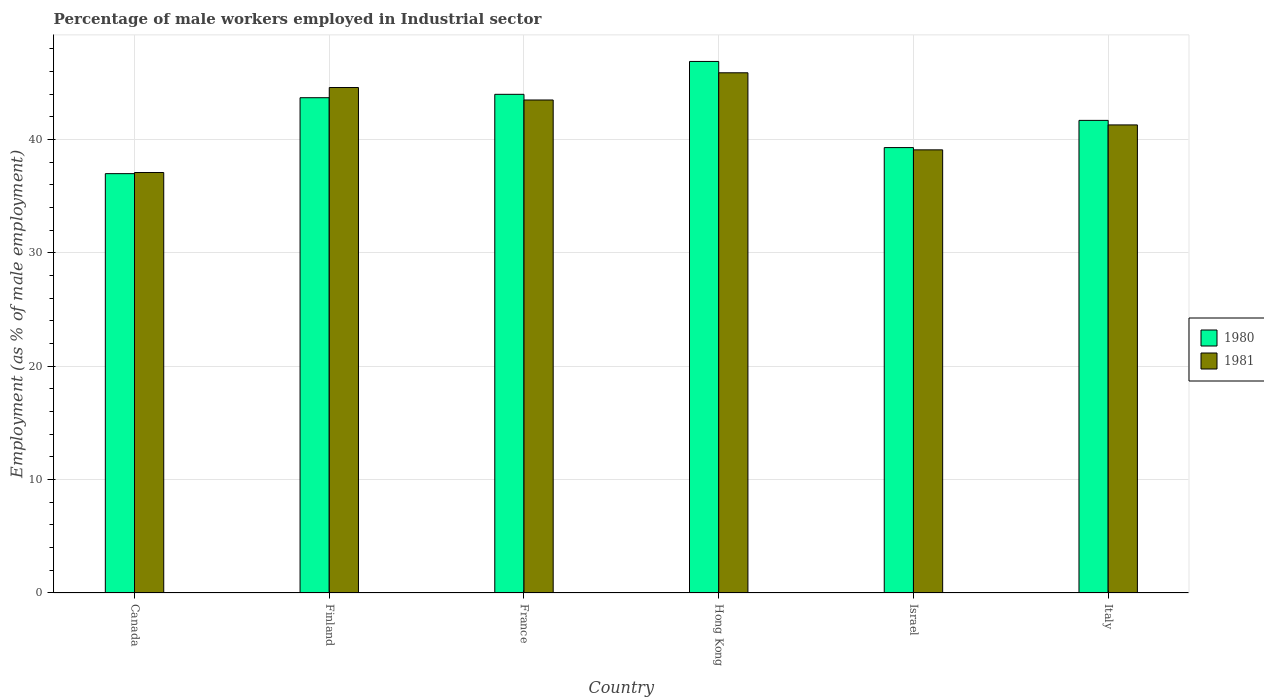How many different coloured bars are there?
Provide a succinct answer. 2. How many groups of bars are there?
Ensure brevity in your answer.  6. Are the number of bars on each tick of the X-axis equal?
Your answer should be very brief. Yes. In how many cases, is the number of bars for a given country not equal to the number of legend labels?
Your response must be concise. 0. What is the percentage of male workers employed in Industrial sector in 1980 in Italy?
Give a very brief answer. 41.7. Across all countries, what is the maximum percentage of male workers employed in Industrial sector in 1980?
Keep it short and to the point. 46.9. Across all countries, what is the minimum percentage of male workers employed in Industrial sector in 1981?
Make the answer very short. 37.1. In which country was the percentage of male workers employed in Industrial sector in 1980 maximum?
Offer a very short reply. Hong Kong. What is the total percentage of male workers employed in Industrial sector in 1980 in the graph?
Provide a short and direct response. 252.6. What is the difference between the percentage of male workers employed in Industrial sector in 1981 in Canada and that in Finland?
Give a very brief answer. -7.5. What is the difference between the percentage of male workers employed in Industrial sector in 1980 in Israel and the percentage of male workers employed in Industrial sector in 1981 in Canada?
Offer a terse response. 2.2. What is the average percentage of male workers employed in Industrial sector in 1980 per country?
Your answer should be very brief. 42.1. What is the difference between the percentage of male workers employed in Industrial sector of/in 1980 and percentage of male workers employed in Industrial sector of/in 1981 in Finland?
Ensure brevity in your answer.  -0.9. In how many countries, is the percentage of male workers employed in Industrial sector in 1980 greater than 30 %?
Ensure brevity in your answer.  6. What is the ratio of the percentage of male workers employed in Industrial sector in 1980 in Canada to that in Finland?
Your answer should be very brief. 0.85. Is the percentage of male workers employed in Industrial sector in 1980 in Canada less than that in Israel?
Provide a succinct answer. Yes. What is the difference between the highest and the second highest percentage of male workers employed in Industrial sector in 1980?
Your answer should be compact. -0.3. What is the difference between the highest and the lowest percentage of male workers employed in Industrial sector in 1980?
Make the answer very short. 9.9. What does the 1st bar from the left in Finland represents?
Offer a very short reply. 1980. How many countries are there in the graph?
Provide a succinct answer. 6. Does the graph contain grids?
Give a very brief answer. Yes. Where does the legend appear in the graph?
Keep it short and to the point. Center right. How many legend labels are there?
Provide a succinct answer. 2. What is the title of the graph?
Offer a terse response. Percentage of male workers employed in Industrial sector. Does "2002" appear as one of the legend labels in the graph?
Your response must be concise. No. What is the label or title of the Y-axis?
Offer a very short reply. Employment (as % of male employment). What is the Employment (as % of male employment) of 1980 in Canada?
Provide a succinct answer. 37. What is the Employment (as % of male employment) of 1981 in Canada?
Your answer should be compact. 37.1. What is the Employment (as % of male employment) of 1980 in Finland?
Offer a terse response. 43.7. What is the Employment (as % of male employment) in 1981 in Finland?
Your answer should be compact. 44.6. What is the Employment (as % of male employment) of 1980 in France?
Provide a succinct answer. 44. What is the Employment (as % of male employment) in 1981 in France?
Provide a succinct answer. 43.5. What is the Employment (as % of male employment) in 1980 in Hong Kong?
Your answer should be compact. 46.9. What is the Employment (as % of male employment) in 1981 in Hong Kong?
Provide a succinct answer. 45.9. What is the Employment (as % of male employment) of 1980 in Israel?
Make the answer very short. 39.3. What is the Employment (as % of male employment) of 1981 in Israel?
Offer a very short reply. 39.1. What is the Employment (as % of male employment) of 1980 in Italy?
Your answer should be compact. 41.7. What is the Employment (as % of male employment) in 1981 in Italy?
Make the answer very short. 41.3. Across all countries, what is the maximum Employment (as % of male employment) in 1980?
Your response must be concise. 46.9. Across all countries, what is the maximum Employment (as % of male employment) of 1981?
Provide a succinct answer. 45.9. Across all countries, what is the minimum Employment (as % of male employment) in 1980?
Give a very brief answer. 37. Across all countries, what is the minimum Employment (as % of male employment) of 1981?
Keep it short and to the point. 37.1. What is the total Employment (as % of male employment) of 1980 in the graph?
Your answer should be very brief. 252.6. What is the total Employment (as % of male employment) in 1981 in the graph?
Your answer should be compact. 251.5. What is the difference between the Employment (as % of male employment) in 1980 in Canada and that in France?
Offer a very short reply. -7. What is the difference between the Employment (as % of male employment) of 1981 in Canada and that in Hong Kong?
Your answer should be very brief. -8.8. What is the difference between the Employment (as % of male employment) of 1981 in Canada and that in Italy?
Offer a very short reply. -4.2. What is the difference between the Employment (as % of male employment) of 1980 in Finland and that in Hong Kong?
Your answer should be very brief. -3.2. What is the difference between the Employment (as % of male employment) in 1981 in Finland and that in Hong Kong?
Make the answer very short. -1.3. What is the difference between the Employment (as % of male employment) in 1980 in Finland and that in Israel?
Make the answer very short. 4.4. What is the difference between the Employment (as % of male employment) in 1981 in Finland and that in Israel?
Provide a succinct answer. 5.5. What is the difference between the Employment (as % of male employment) in 1981 in Finland and that in Italy?
Provide a short and direct response. 3.3. What is the difference between the Employment (as % of male employment) in 1981 in France and that in Hong Kong?
Your response must be concise. -2.4. What is the difference between the Employment (as % of male employment) of 1980 in France and that in Israel?
Your response must be concise. 4.7. What is the difference between the Employment (as % of male employment) in 1981 in France and that in Israel?
Offer a very short reply. 4.4. What is the difference between the Employment (as % of male employment) in 1980 in France and that in Italy?
Make the answer very short. 2.3. What is the difference between the Employment (as % of male employment) in 1980 in Hong Kong and that in Israel?
Give a very brief answer. 7.6. What is the difference between the Employment (as % of male employment) of 1981 in Hong Kong and that in Israel?
Your answer should be very brief. 6.8. What is the difference between the Employment (as % of male employment) in 1981 in Hong Kong and that in Italy?
Give a very brief answer. 4.6. What is the difference between the Employment (as % of male employment) in 1980 in Canada and the Employment (as % of male employment) in 1981 in France?
Keep it short and to the point. -6.5. What is the difference between the Employment (as % of male employment) of 1980 in Canada and the Employment (as % of male employment) of 1981 in Hong Kong?
Provide a short and direct response. -8.9. What is the difference between the Employment (as % of male employment) of 1980 in Canada and the Employment (as % of male employment) of 1981 in Italy?
Provide a short and direct response. -4.3. What is the difference between the Employment (as % of male employment) in 1980 in France and the Employment (as % of male employment) in 1981 in Israel?
Make the answer very short. 4.9. What is the difference between the Employment (as % of male employment) of 1980 in Hong Kong and the Employment (as % of male employment) of 1981 in Israel?
Keep it short and to the point. 7.8. What is the difference between the Employment (as % of male employment) in 1980 in Hong Kong and the Employment (as % of male employment) in 1981 in Italy?
Your response must be concise. 5.6. What is the average Employment (as % of male employment) of 1980 per country?
Offer a terse response. 42.1. What is the average Employment (as % of male employment) in 1981 per country?
Make the answer very short. 41.92. What is the difference between the Employment (as % of male employment) of 1980 and Employment (as % of male employment) of 1981 in France?
Make the answer very short. 0.5. What is the ratio of the Employment (as % of male employment) in 1980 in Canada to that in Finland?
Keep it short and to the point. 0.85. What is the ratio of the Employment (as % of male employment) in 1981 in Canada to that in Finland?
Make the answer very short. 0.83. What is the ratio of the Employment (as % of male employment) of 1980 in Canada to that in France?
Ensure brevity in your answer.  0.84. What is the ratio of the Employment (as % of male employment) in 1981 in Canada to that in France?
Your response must be concise. 0.85. What is the ratio of the Employment (as % of male employment) of 1980 in Canada to that in Hong Kong?
Your response must be concise. 0.79. What is the ratio of the Employment (as % of male employment) of 1981 in Canada to that in Hong Kong?
Your response must be concise. 0.81. What is the ratio of the Employment (as % of male employment) of 1980 in Canada to that in Israel?
Provide a succinct answer. 0.94. What is the ratio of the Employment (as % of male employment) in 1981 in Canada to that in Israel?
Your answer should be very brief. 0.95. What is the ratio of the Employment (as % of male employment) of 1980 in Canada to that in Italy?
Give a very brief answer. 0.89. What is the ratio of the Employment (as % of male employment) of 1981 in Canada to that in Italy?
Offer a terse response. 0.9. What is the ratio of the Employment (as % of male employment) in 1981 in Finland to that in France?
Make the answer very short. 1.03. What is the ratio of the Employment (as % of male employment) of 1980 in Finland to that in Hong Kong?
Provide a short and direct response. 0.93. What is the ratio of the Employment (as % of male employment) of 1981 in Finland to that in Hong Kong?
Provide a short and direct response. 0.97. What is the ratio of the Employment (as % of male employment) in 1980 in Finland to that in Israel?
Your response must be concise. 1.11. What is the ratio of the Employment (as % of male employment) of 1981 in Finland to that in Israel?
Your answer should be compact. 1.14. What is the ratio of the Employment (as % of male employment) of 1980 in Finland to that in Italy?
Your answer should be very brief. 1.05. What is the ratio of the Employment (as % of male employment) in 1981 in Finland to that in Italy?
Offer a very short reply. 1.08. What is the ratio of the Employment (as % of male employment) in 1980 in France to that in Hong Kong?
Keep it short and to the point. 0.94. What is the ratio of the Employment (as % of male employment) in 1981 in France to that in Hong Kong?
Offer a terse response. 0.95. What is the ratio of the Employment (as % of male employment) of 1980 in France to that in Israel?
Make the answer very short. 1.12. What is the ratio of the Employment (as % of male employment) of 1981 in France to that in Israel?
Provide a short and direct response. 1.11. What is the ratio of the Employment (as % of male employment) in 1980 in France to that in Italy?
Keep it short and to the point. 1.06. What is the ratio of the Employment (as % of male employment) of 1981 in France to that in Italy?
Your answer should be compact. 1.05. What is the ratio of the Employment (as % of male employment) of 1980 in Hong Kong to that in Israel?
Your answer should be compact. 1.19. What is the ratio of the Employment (as % of male employment) in 1981 in Hong Kong to that in Israel?
Keep it short and to the point. 1.17. What is the ratio of the Employment (as % of male employment) in 1980 in Hong Kong to that in Italy?
Provide a succinct answer. 1.12. What is the ratio of the Employment (as % of male employment) of 1981 in Hong Kong to that in Italy?
Give a very brief answer. 1.11. What is the ratio of the Employment (as % of male employment) in 1980 in Israel to that in Italy?
Ensure brevity in your answer.  0.94. What is the ratio of the Employment (as % of male employment) of 1981 in Israel to that in Italy?
Offer a terse response. 0.95. What is the difference between the highest and the second highest Employment (as % of male employment) in 1980?
Your response must be concise. 2.9. What is the difference between the highest and the second highest Employment (as % of male employment) in 1981?
Offer a terse response. 1.3. What is the difference between the highest and the lowest Employment (as % of male employment) in 1980?
Offer a very short reply. 9.9. What is the difference between the highest and the lowest Employment (as % of male employment) of 1981?
Give a very brief answer. 8.8. 